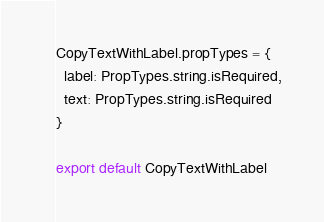<code> <loc_0><loc_0><loc_500><loc_500><_JavaScript_>CopyTextWithLabel.propTypes = {
  label: PropTypes.string.isRequired,
  text: PropTypes.string.isRequired
}

export default CopyTextWithLabel
</code> 